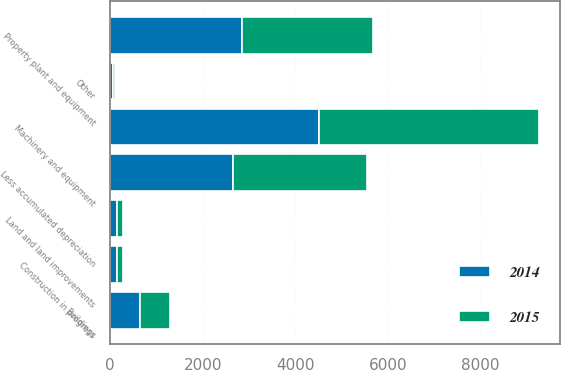Convert chart to OTSL. <chart><loc_0><loc_0><loc_500><loc_500><stacked_bar_chart><ecel><fcel>Land and land improvements<fcel>Buildings<fcel>Machinery and equipment<fcel>Construction in progress<fcel>Other<fcel>Property plant and equipment<fcel>Less accumulated depreciation<nl><fcel>2015<fcel>146.4<fcel>640.9<fcel>4747.1<fcel>119.1<fcel>61.3<fcel>2832.1<fcel>2882.7<nl><fcel>2014<fcel>143.5<fcel>654.6<fcel>4508<fcel>154.8<fcel>54.5<fcel>2857.6<fcel>2657.8<nl></chart> 